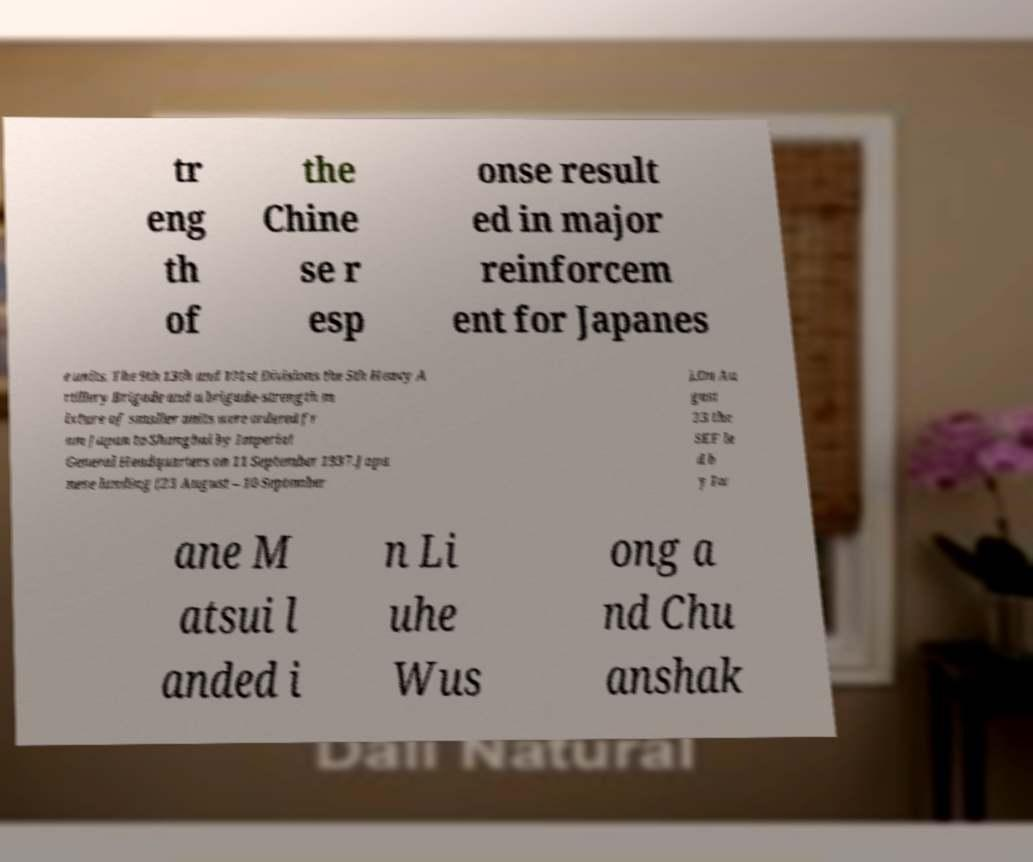Could you assist in decoding the text presented in this image and type it out clearly? tr eng th of the Chine se r esp onse result ed in major reinforcem ent for Japanes e units. The 9th 13th and 101st Divisions the 5th Heavy A rtillery Brigade and a brigade-strength m ixture of smaller units were ordered fr om Japan to Shanghai by Imperial General Headquarters on 11 September 1937.Japa nese landing (23 August – 10 September ).On Au gust 23 the SEF le d b y Iw ane M atsui l anded i n Li uhe Wus ong a nd Chu anshak 